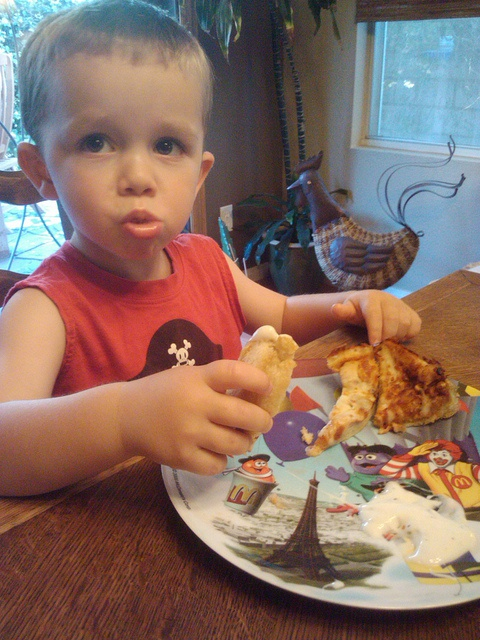Describe the objects in this image and their specific colors. I can see people in ivory, brown, tan, and maroon tones, dining table in ivory, maroon, black, tan, and brown tones, pizza in ivory, brown, tan, maroon, and orange tones, chair in ivory, lightblue, and darkgray tones, and chair in ivory, gray, lightblue, and white tones in this image. 